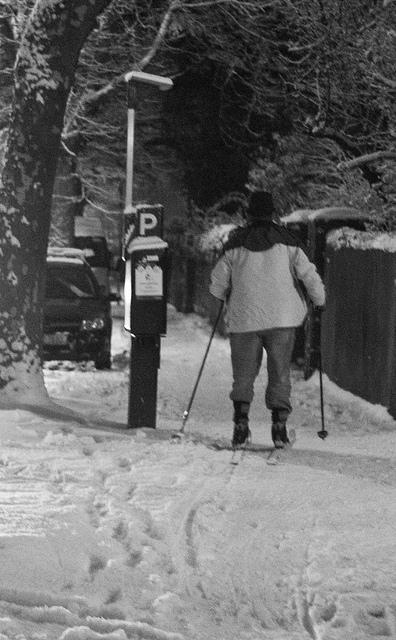What type of area is this? sidewalk 